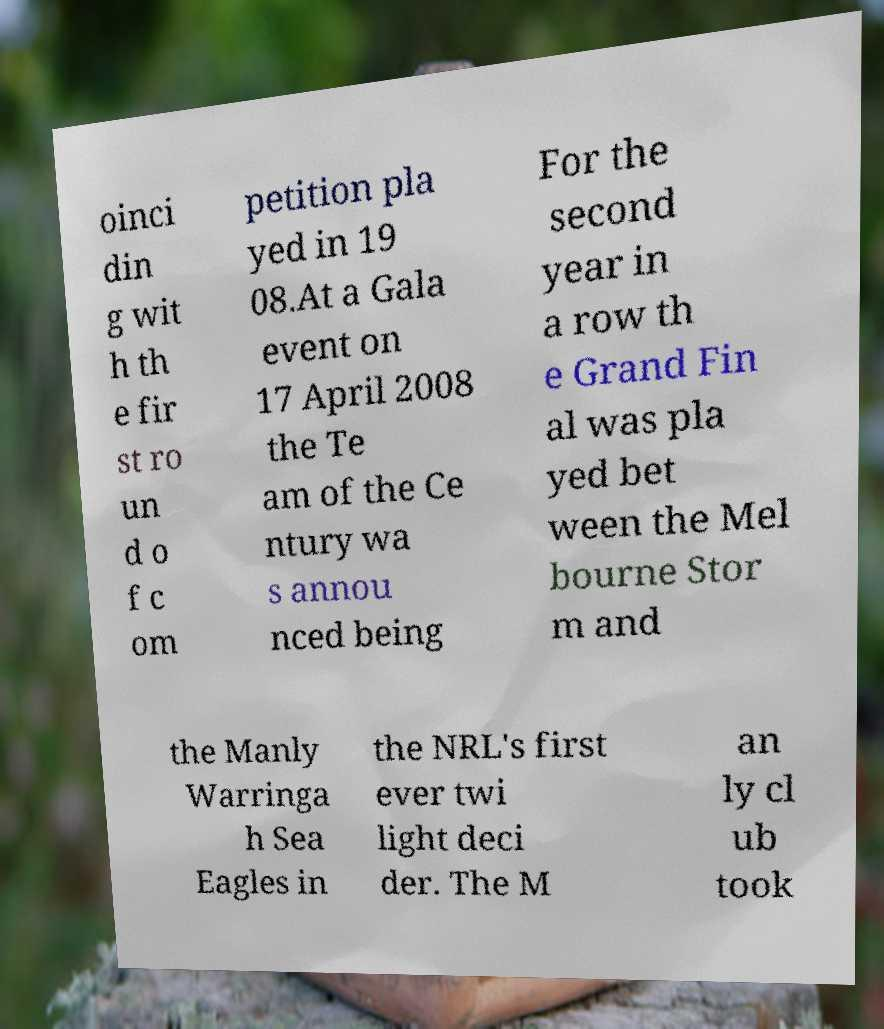Can you read and provide the text displayed in the image?This photo seems to have some interesting text. Can you extract and type it out for me? oinci din g wit h th e fir st ro un d o f c om petition pla yed in 19 08.At a Gala event on 17 April 2008 the Te am of the Ce ntury wa s annou nced being For the second year in a row th e Grand Fin al was pla yed bet ween the Mel bourne Stor m and the Manly Warringa h Sea Eagles in the NRL's first ever twi light deci der. The M an ly cl ub took 